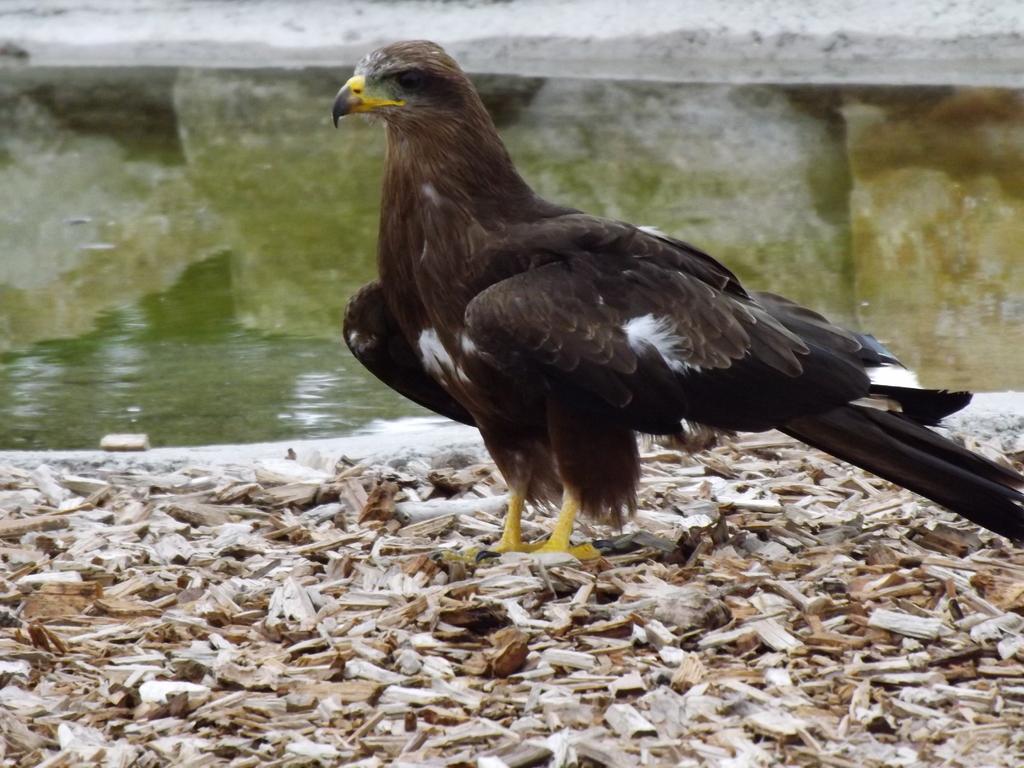Describe this image in one or two sentences. In this picture we can see an eagle and behind the eagle where is the water. On the water we can see the reflection of the rocks. 